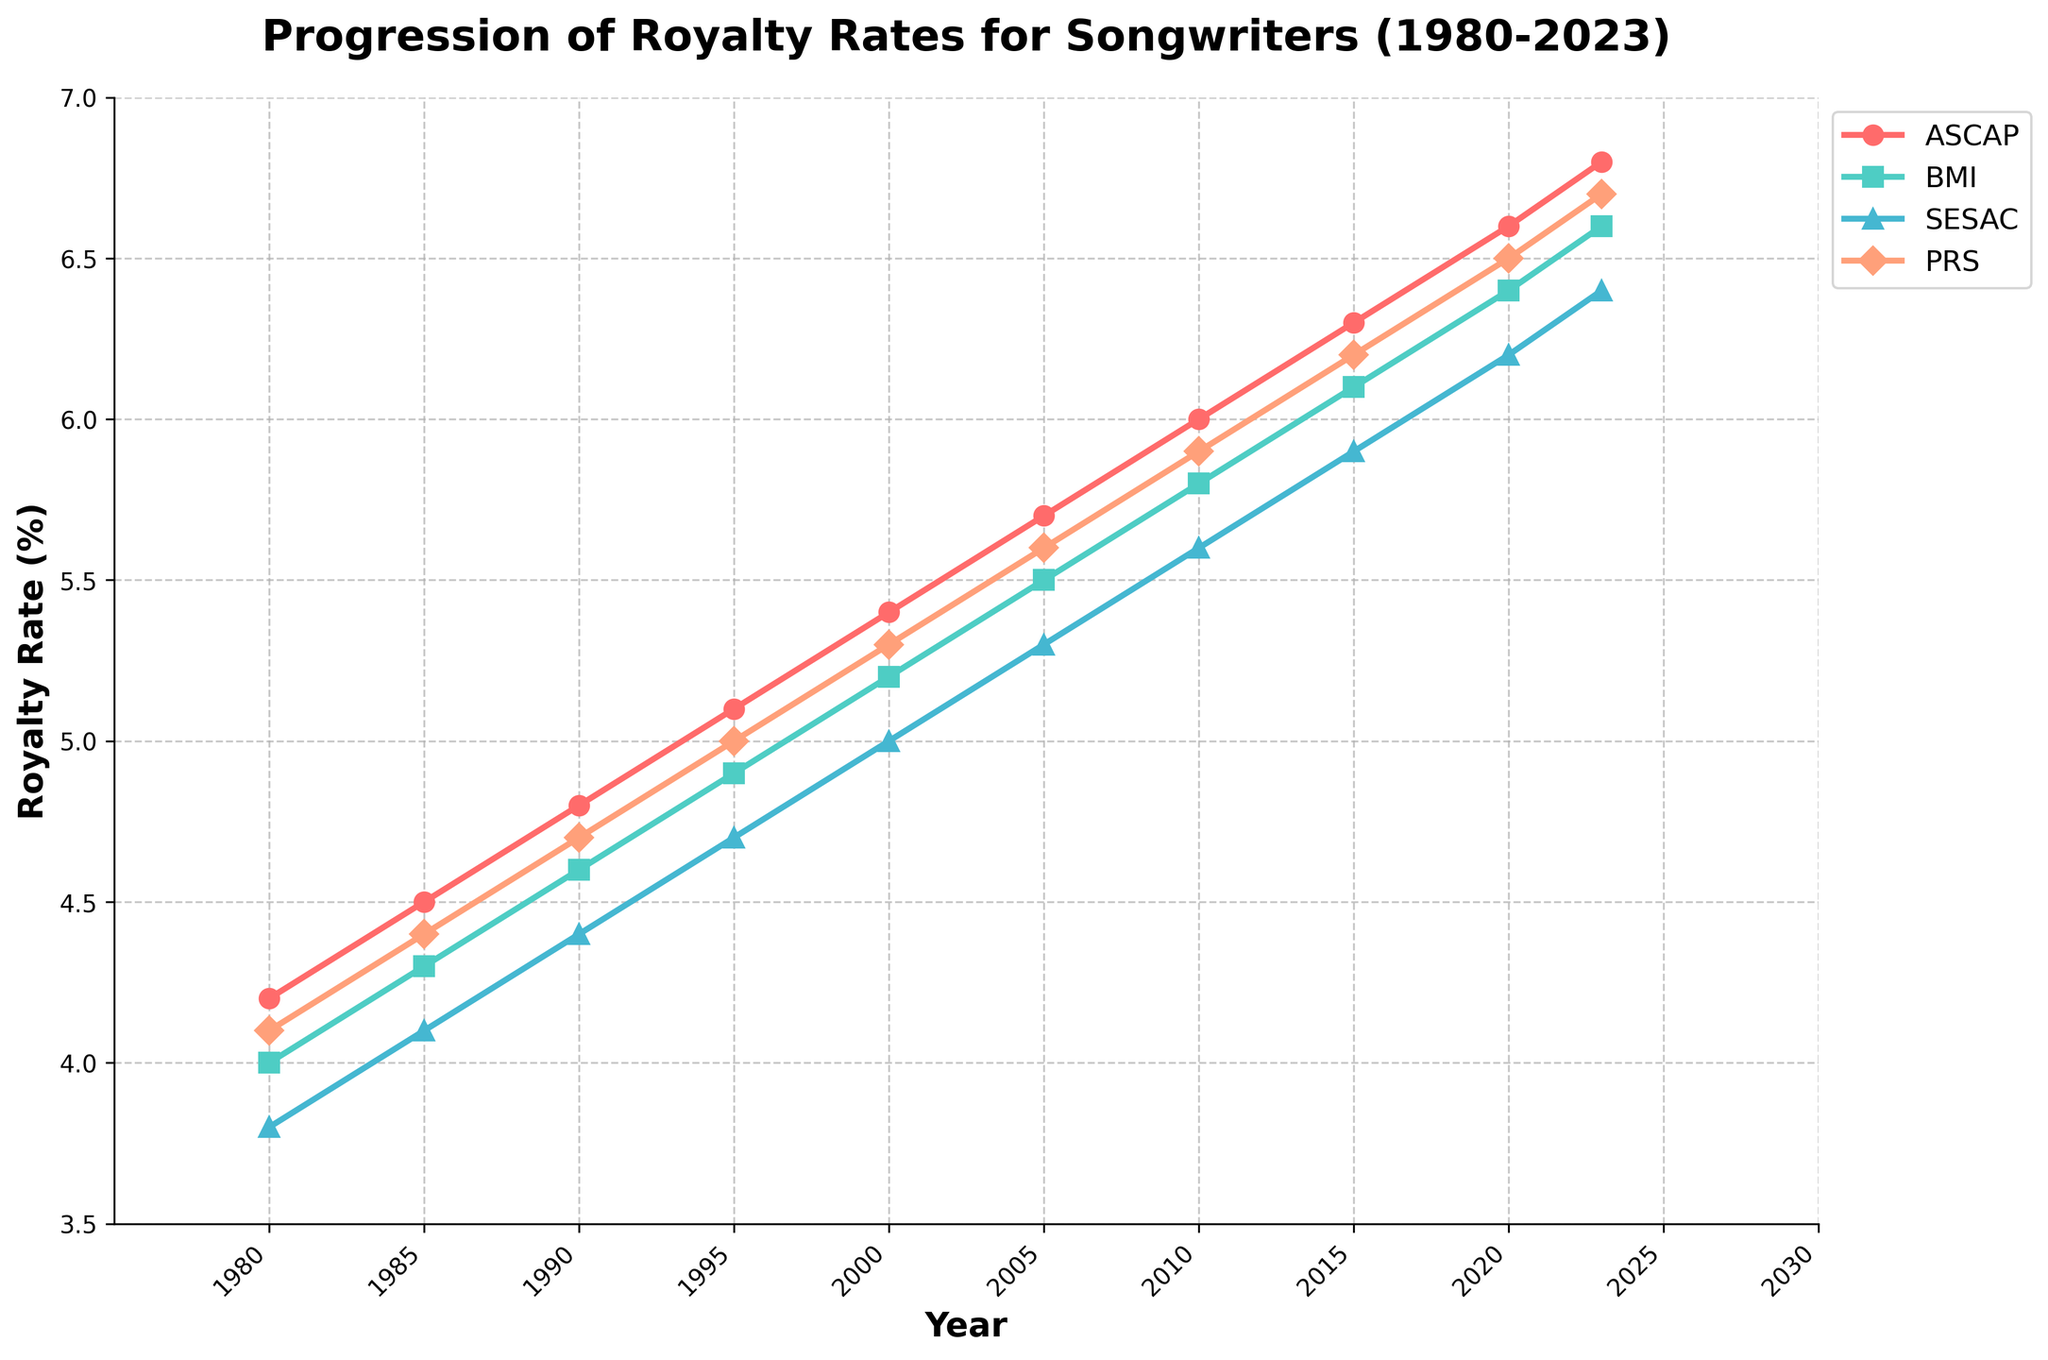What's the overall trend for ASCAP's royalty rates from 1980 to 2023? The line for ASCAP shows a consistent upward trend from 4.2 in 1980 to 6.8 in 2023. This indicates a steady increase in royalty rates over the years.
Answer: Steady increase Which organization had the highest royalty rate in 2023? By examining the graph, PRS had the highest royalty rate at 6.7% in 2023. Although ASCAP was close with 6.8%, PRS is just slightly higher.
Answer: ASCAP What is the average royalty rate for BMI between 2000 and 2023? The data points for BMI between 2000 and 2023 are 5.2, 5.5, 5.8, 6.1, 6.4, 6.6. Adding these values gives 35.6, and dividing by 6 gives the average royalty rate of 5.93.
Answer: 5.93 How does SESAC's rate of increase compare to BMI's between 1980 and 2023? SESAC increased from 3.8 to 6.4, a change of 2.6. BMI increased from 4.0 to 6.6, a change of 2.6. Both SESAC and BMI had the same total increase of 2.6 percentage points over this period.
Answer: Same Which organization's royalty rates saw the smallest increase from 1980 to 2023? By comparing the initial and final values: ASCAP (4.2 to 6.8: 2.6 increase), BMI (4.0 to 6.6: 2.6 increase), SESAC (3.8 to 6.4: 2.6 increase), PRS (4.1 to 6.7: 2.6 increase). All organizations saw the same increase of 2.6 percentage points.
Answer: All equal In which year did BMI's royalty rate surpass 6%? Referring to the graph, BMI's rate surpassed 6% in 2020 when it reached 6.4%.
Answer: 2020 By how much did PRS's royalty rate change between 1980 and 1990? PRS's rate changed from 4.1 to 4.7 between 1980 and 1990. The difference is 4.7 - 4.1 = 0.6 percentage points.
Answer: 0.6 What can you say about the stability of royalty rates for SESAC between 2010 and 2023? The rate for SESAC moved from 5.6 in 2010 to 6.4 in 2023, showing a steadily increasing trend, with changes of roughly 0.1–0.2 percentage points every five years. This indicates quite stable but steadily increasing rates.
Answer: Steadily increasing Which year showed a stepwise increase in royalty rates for all organizations? The graph shows stepwise increases around every five years. The year 2010 is a notable point where all organizations had increased from their previous values in 2005.
Answer: 2010 